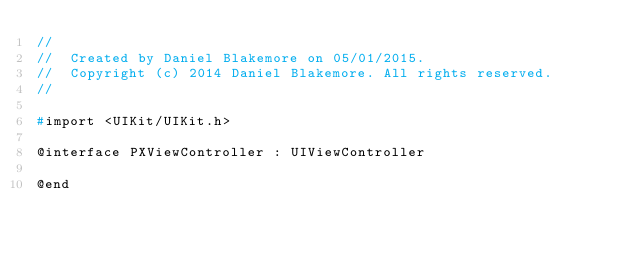<code> <loc_0><loc_0><loc_500><loc_500><_C_>//
//  Created by Daniel Blakemore on 05/01/2015.
//  Copyright (c) 2014 Daniel Blakemore. All rights reserved.
//

#import <UIKit/UIKit.h>

@interface PXViewController : UIViewController

@end
</code> 